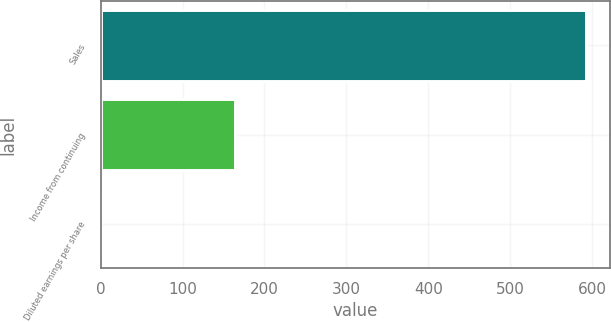Convert chart to OTSL. <chart><loc_0><loc_0><loc_500><loc_500><bar_chart><fcel>Sales<fcel>Income from continuing<fcel>Diluted earnings per share<nl><fcel>592.1<fcel>164.3<fcel>0.92<nl></chart> 